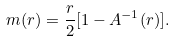Convert formula to latex. <formula><loc_0><loc_0><loc_500><loc_500>m ( r ) = \frac { r } { 2 } [ 1 - A ^ { - 1 } ( r ) ] .</formula> 